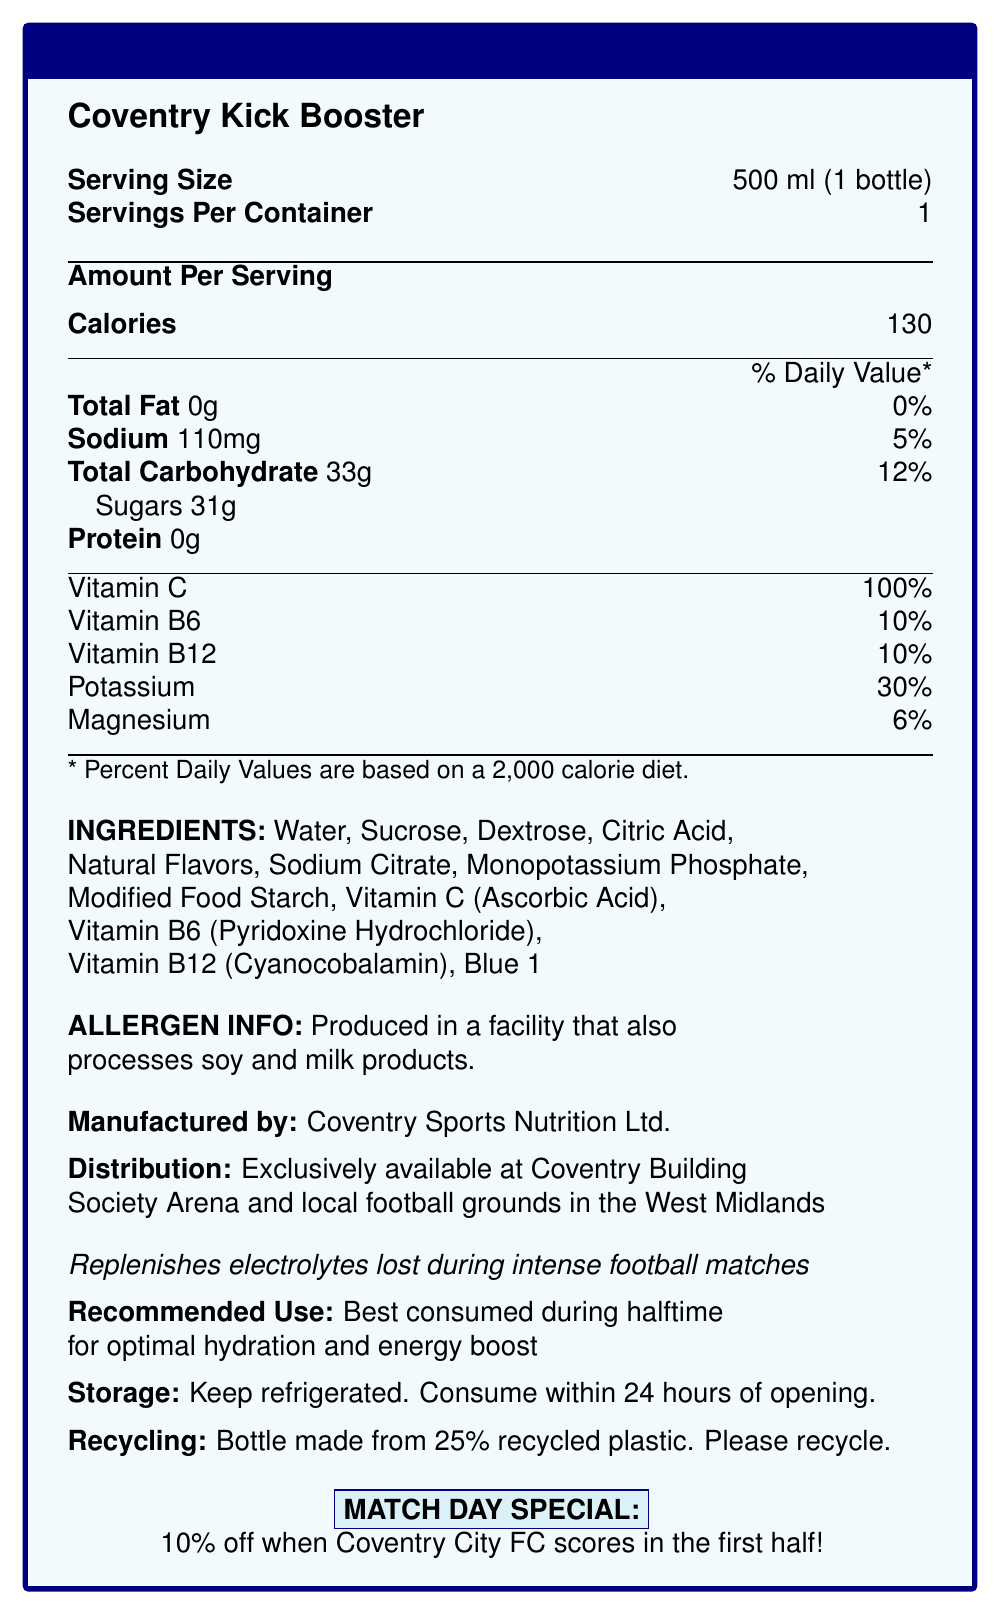What is the serving size for Coventry Kick Booster? The serving size is clearly indicated as 500 ml, equivalent to 1 bottle.
Answer: 500 ml (1 bottle) How many calories are there per serving of Coventry Kick Booster? The document states that there are 130 calories per serving.
Answer: 130 What percentage of the daily value of Vitamin C does one serving of this sports drink provide? The label indicates that one serving provides 100% of the daily value for Vitamin C.
Answer: 100% Which ingredient is listed first in Coventry Kick Booster? The ingredients are listed in order of quantity, and water is the first ingredient mentioned.
Answer: Water What is the main use recommended for Coventry Kick Booster during a football match? The document recommends consuming the drink during halftime for optimal hydration and energy boost.
Answer: Best consumed during halftime for optimal hydration and energy boost Which company manufactures the Coventry Kick Booster? The manufacturer is clearly mentioned as Coventry Sports Nutrition Ltd.
Answer: Coventry Sports Nutrition Ltd. Is this sports drink suitable for someone allergic to soy or milk products? The allergen information states that the drink is produced in a facility that also processes soy and milk products, which may not be suitable for someone with such allergies.
Answer: No What percentage of the daily value of sodium is in one serving of Coventry Kick Booster? The label indicates that one serving provides 5% of the daily value for sodium.
Answer: 5% How should the Coventry Kick Booster be stored? The storage instructions specify to keep the drink refrigerated and to consume it within 24 hours of opening.
Answer: Keep refrigerated. Consume within 24 hours of opening. Which of the following vitamins are included in the Coventry Kick Booster? A. Vitamin D B. Vitamin B6 C. Vitamin E D. Vitamin K The document lists Vitamin B6 as an included nutrient.
Answer: B. Vitamin B6 Where can you exclusively purchase the Coventry Kick Booster? A. Supermarkets B. Gyms C. Coventry Building Society Arena and local football grounds in the West Midlands The distribution details specify that the drink is exclusively available at the Coventry Building Society Arena and local football grounds in the West Midlands.
Answer: C. Coventry Building Society Arena and local football grounds in the West Midlands Does the document claim that Coventry Kick Booster helps during intense football matches? The claim is that the drink replenishes electrolytes lost during intense football matches.
Answer: Yes Summarize the main features of the Coventry Kick Booster drink. The document presents Coventry Kick Booster as a specialized sports drink meant to boost hydration and energy levels. It details its nutritional content, recommended use, and exclusivity in terms of distribution, along with recycling and allergen information.
Answer: Coventry Kick Booster is a sports drink designed for hydration and energy replenishment during halftime of football matches. It contains 130 calories per serving with a combination of vitamins and electrolytes. The drink is manufactured by Coventry Sports Nutrition Ltd. and is exclusively available at Coventry Building Society Arena and local football grounds in the West Midlands. It should be refrigerated and consumed within 24 hours of opening. The bottle is made from 25% recycled plastic. What is the special offer related to Coventry City FC? The match day special offers 10% off when Coventry City FC scores in the first half.
Answer: 10% off when Coventry City FC scores in the first half What type of plastic is used for the Coventry Kick Booster bottle? The document states that the bottle is made from 25% recycled plastic but does not specify the type of plastic used.
Answer: Not mentioned 